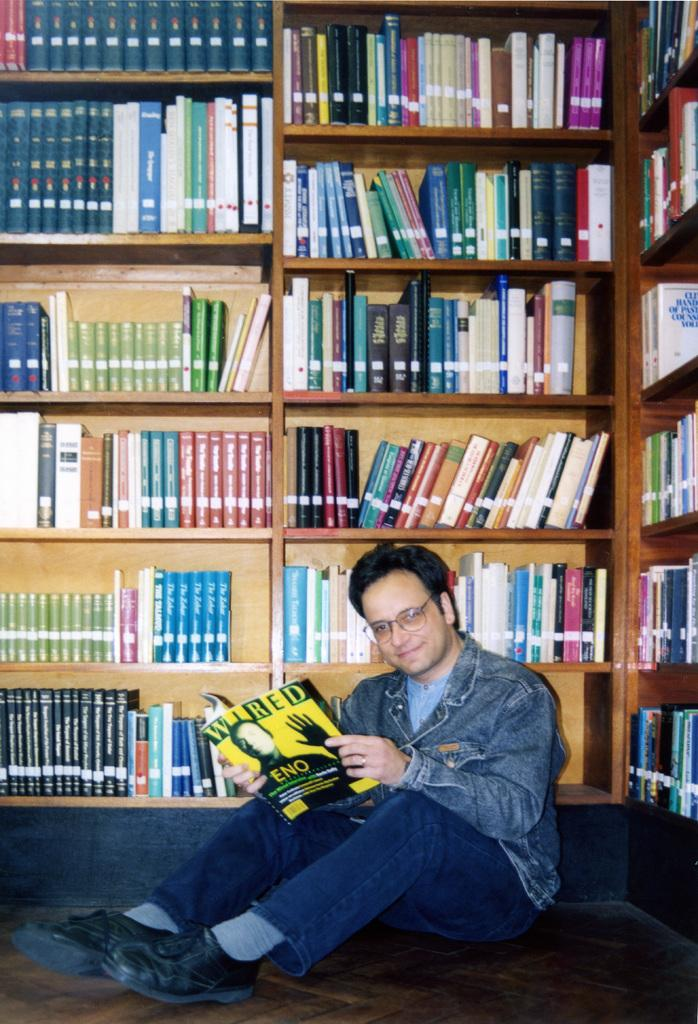What is the man in the image doing? The man is sitting on the floor in the image. What is the man holding in his hands? The man is holding a book in his hands. What can be seen in the background of the image? There are many books arranged in rows in the cupboard in the background of the image. What type of cast can be seen on the man's leg in the image? There is no cast visible on the man's leg in the image. What kind of plough is the man using to cultivate the field in the image? There is no plough or field present in the image; it features a man sitting on the floor holding a book. 